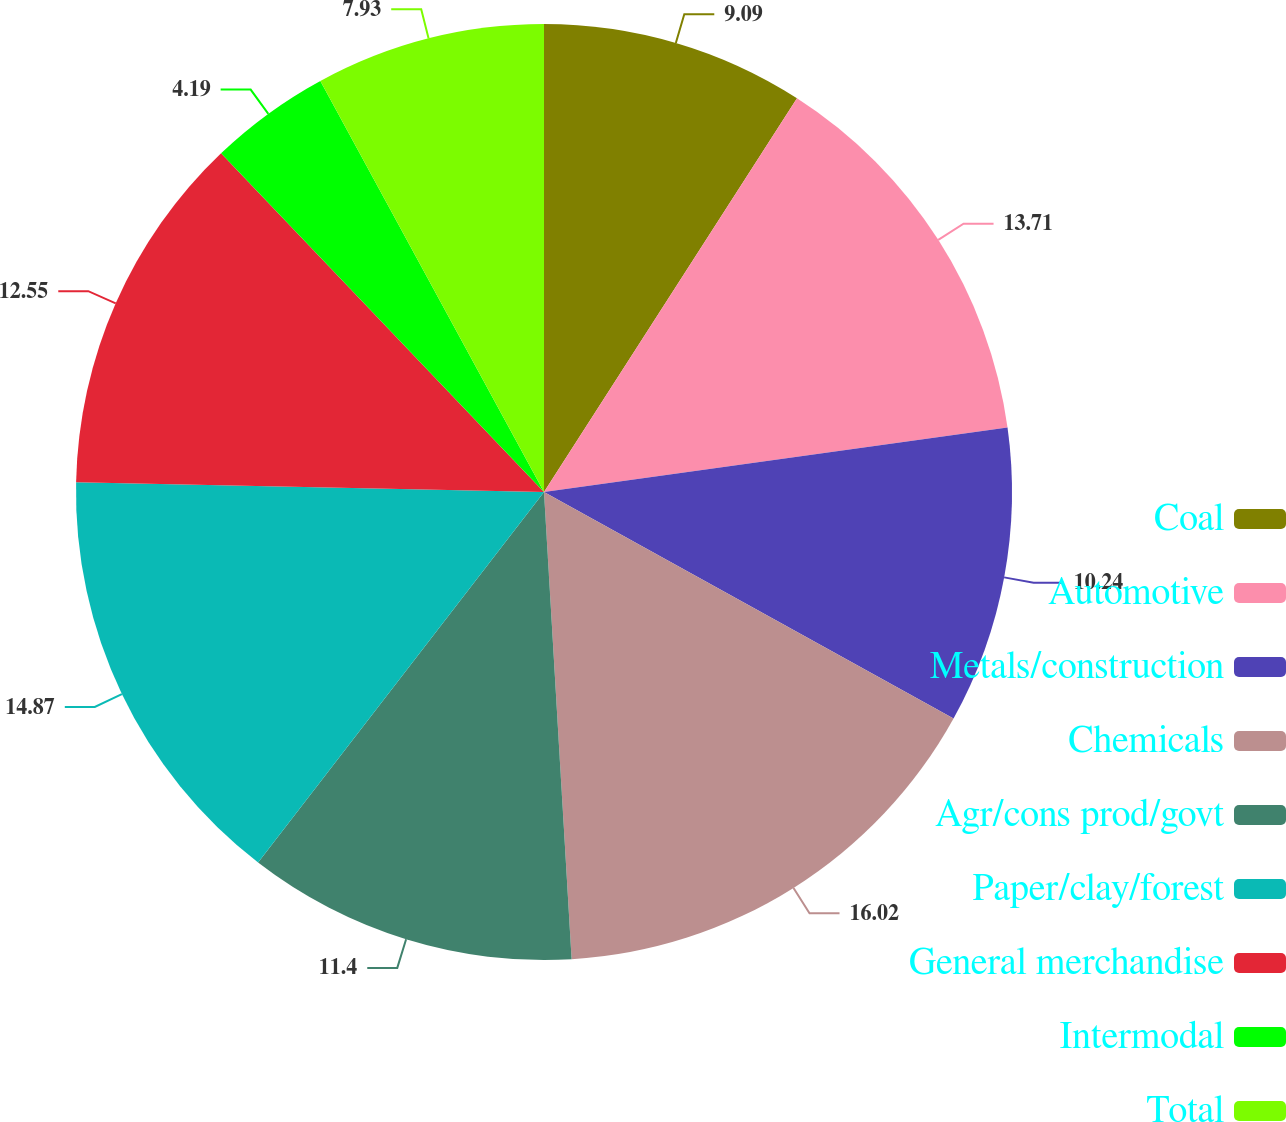<chart> <loc_0><loc_0><loc_500><loc_500><pie_chart><fcel>Coal<fcel>Automotive<fcel>Metals/construction<fcel>Chemicals<fcel>Agr/cons prod/govt<fcel>Paper/clay/forest<fcel>General merchandise<fcel>Intermodal<fcel>Total<nl><fcel>9.09%<fcel>13.71%<fcel>10.24%<fcel>16.02%<fcel>11.4%<fcel>14.87%<fcel>12.55%<fcel>4.19%<fcel>7.93%<nl></chart> 